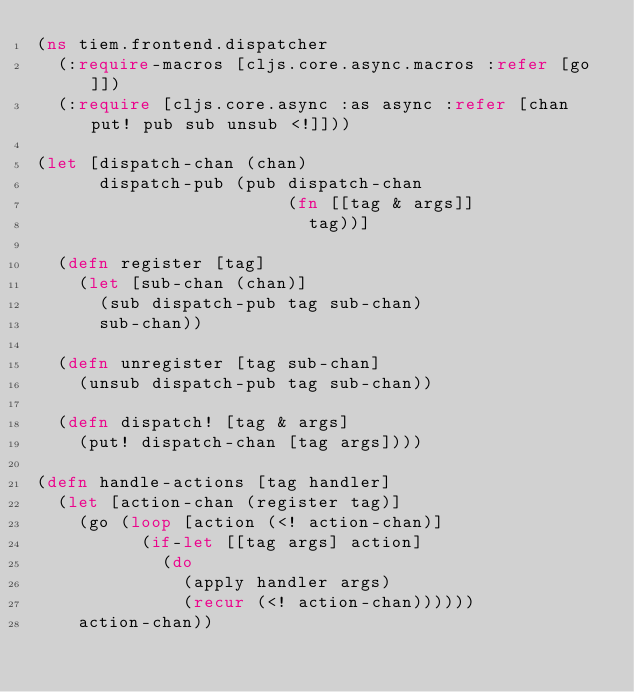Convert code to text. <code><loc_0><loc_0><loc_500><loc_500><_Clojure_>(ns tiem.frontend.dispatcher
  (:require-macros [cljs.core.async.macros :refer [go]])
  (:require [cljs.core.async :as async :refer [chan put! pub sub unsub <!]]))

(let [dispatch-chan (chan)
      dispatch-pub (pub dispatch-chan
                        (fn [[tag & args]]
                          tag))]

  (defn register [tag]
    (let [sub-chan (chan)]
      (sub dispatch-pub tag sub-chan)
      sub-chan))

  (defn unregister [tag sub-chan]
    (unsub dispatch-pub tag sub-chan))

  (defn dispatch! [tag & args]
    (put! dispatch-chan [tag args])))

(defn handle-actions [tag handler]
  (let [action-chan (register tag)]
    (go (loop [action (<! action-chan)]
          (if-let [[tag args] action]
            (do
              (apply handler args)
              (recur (<! action-chan))))))
    action-chan))
</code> 